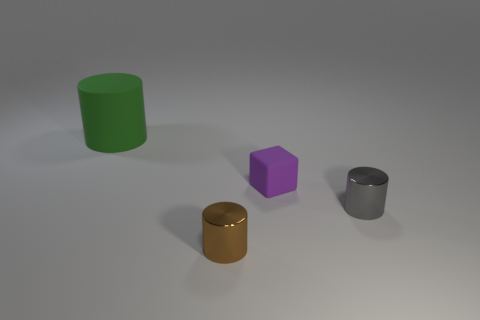What material is the small gray thing that is the same shape as the big object?
Your response must be concise. Metal. There is a metallic cylinder to the right of the purple block; does it have the same color as the matte thing that is on the right side of the small brown shiny thing?
Provide a short and direct response. No. There is a brown cylinder that is the same size as the gray metal thing; what material is it?
Offer a terse response. Metal. Are there any brown objects that have the same size as the green thing?
Offer a terse response. No. Are there fewer green matte things that are to the left of the matte cylinder than large things?
Offer a very short reply. Yes. Is the number of purple cubes in front of the gray metal cylinder less than the number of purple matte objects that are to the left of the green matte thing?
Give a very brief answer. No. How many balls are big rubber things or matte things?
Ensure brevity in your answer.  0. Is the thing that is behind the tiny purple matte thing made of the same material as the cylinder on the right side of the brown thing?
Provide a short and direct response. No. What shape is the brown object that is the same size as the gray shiny thing?
Offer a very short reply. Cylinder. How many other objects are the same color as the tiny rubber cube?
Keep it short and to the point. 0. 